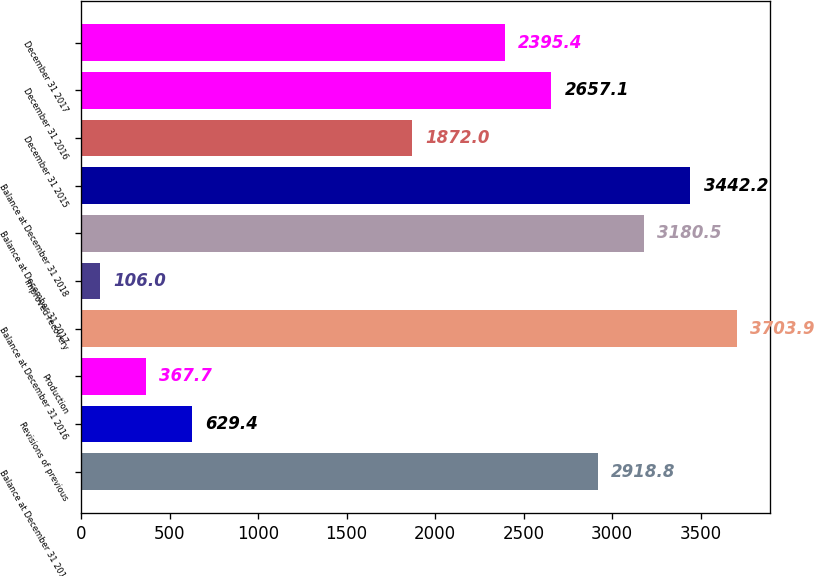Convert chart. <chart><loc_0><loc_0><loc_500><loc_500><bar_chart><fcel>Balance at December 31 2015<fcel>Revisions of previous<fcel>Production<fcel>Balance at December 31 2016<fcel>Improved recovery<fcel>Balance at December 31 2017<fcel>Balance at December 31 2018<fcel>December 31 2015<fcel>December 31 2016<fcel>December 31 2017<nl><fcel>2918.8<fcel>629.4<fcel>367.7<fcel>3703.9<fcel>106<fcel>3180.5<fcel>3442.2<fcel>1872<fcel>2657.1<fcel>2395.4<nl></chart> 